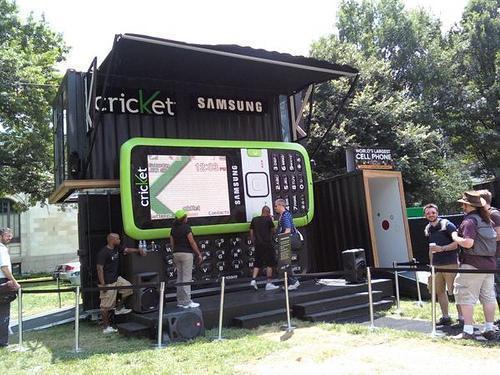Behance network has done most projects on which mobile?
Choose the correct response, then elucidate: 'Answer: answer
Rationale: rationale.'
Options: Samsung, nokia, lenovo, lg. Answer: samsung.
Rationale: A samsung logo can be seen behind a stage people are standing on. 